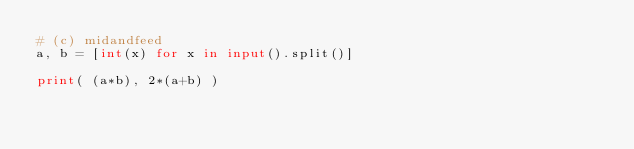Convert code to text. <code><loc_0><loc_0><loc_500><loc_500><_Python_># (c) midandfeed
a, b = [int(x) for x in input().split()]

print( (a*b), 2*(a+b) )</code> 